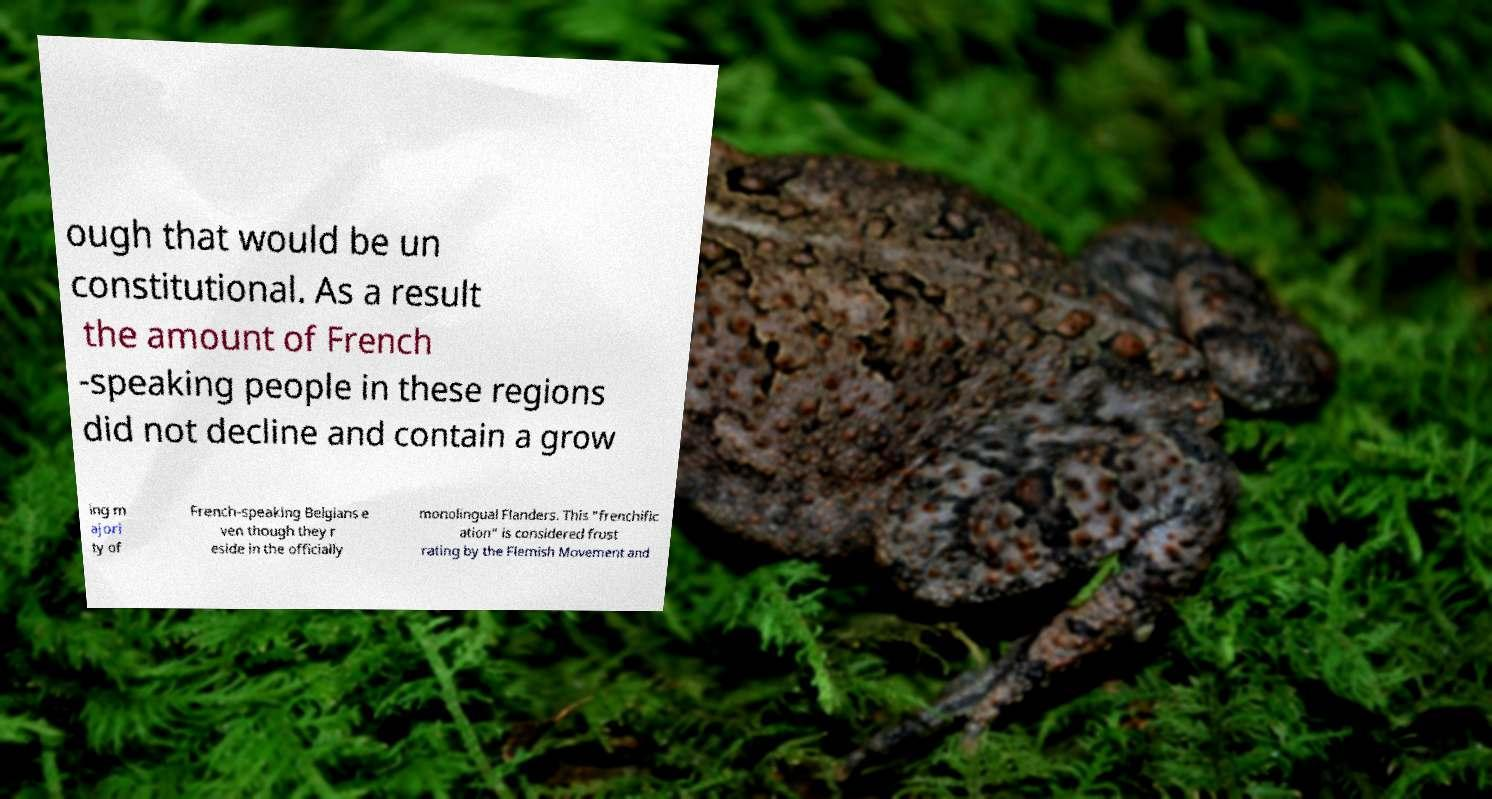Could you assist in decoding the text presented in this image and type it out clearly? ough that would be un constitutional. As a result the amount of French -speaking people in these regions did not decline and contain a grow ing m ajori ty of French-speaking Belgians e ven though they r eside in the officially monolingual Flanders. This "frenchific ation" is considered frust rating by the Flemish Movement and 